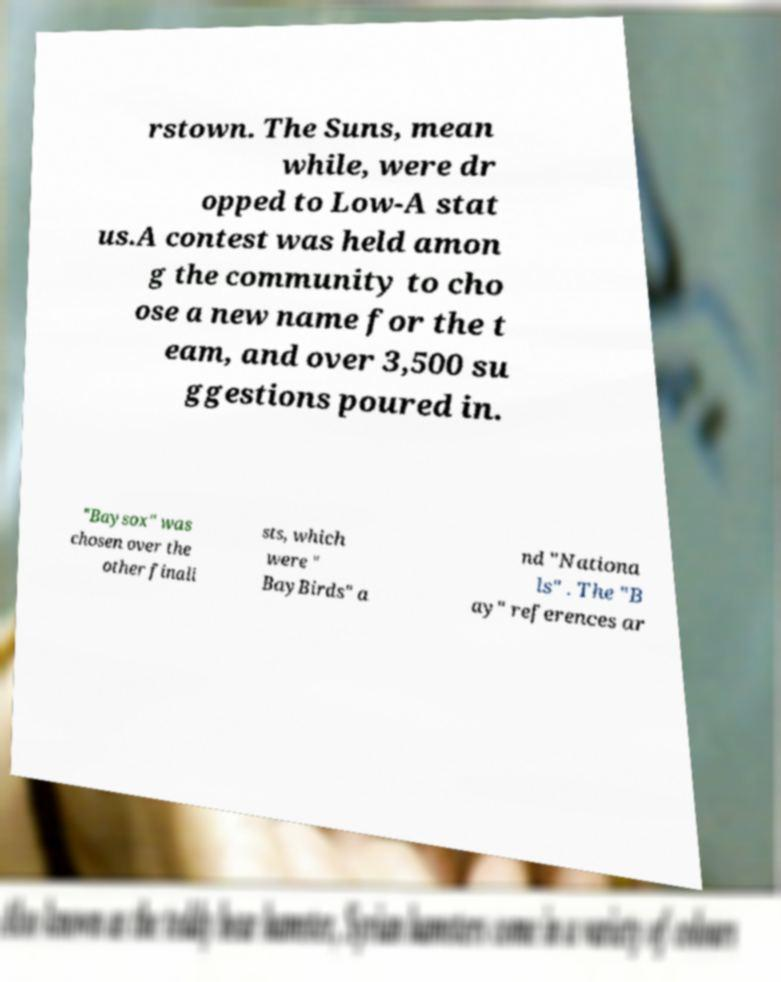Please identify and transcribe the text found in this image. rstown. The Suns, mean while, were dr opped to Low-A stat us.A contest was held amon g the community to cho ose a new name for the t eam, and over 3,500 su ggestions poured in. "Baysox" was chosen over the other finali sts, which were " BayBirds" a nd "Nationa ls" . The "B ay" references ar 